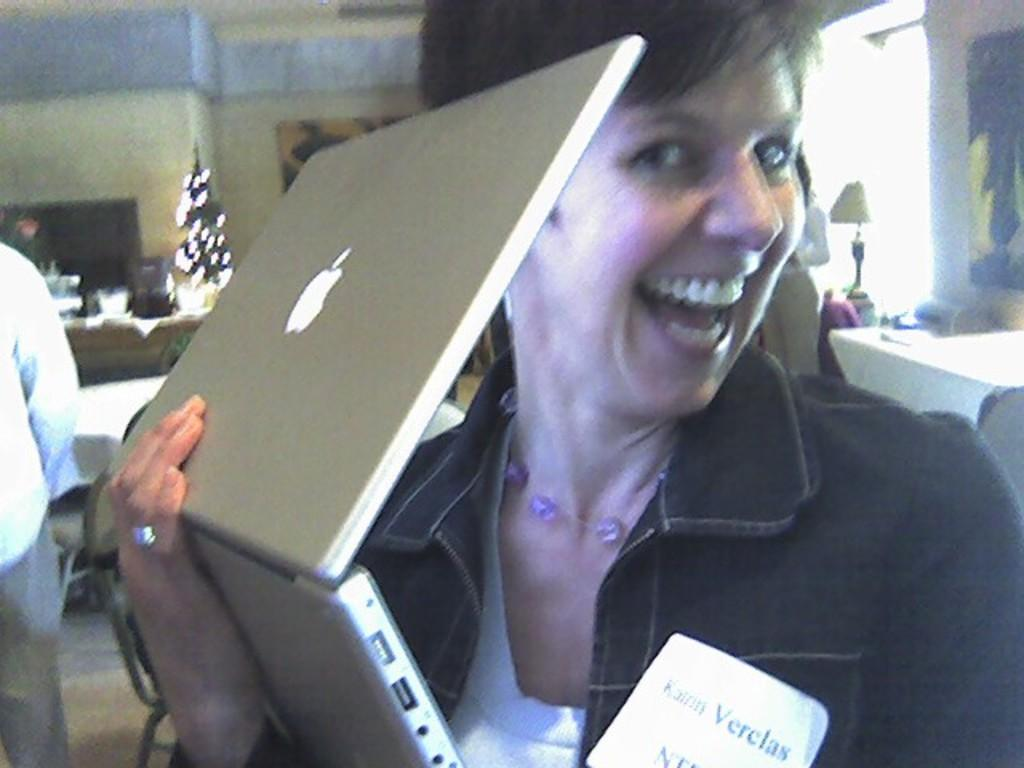Who is the main subject in the image? There is a woman in the image. What is the woman wearing? The woman is wearing a blue jacket. What object is the woman holding? The woman is holding a laptop. What can be seen in the background of the image? There are tables and chairs in the background of the image. What architectural feature is visible to the right of the image? There is a wall with a window to the right of the image. What type of veil is draped over the laptop in the image? There is no veil present in the image; the woman is holding a laptop without any additional coverings. What time does the clock in the image show? There is no clock present in the image, so it is not possible to determine the time. 